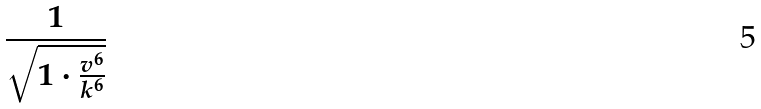<formula> <loc_0><loc_0><loc_500><loc_500>\frac { 1 } { \sqrt { 1 \cdot \frac { v ^ { 6 } } { k ^ { 6 } } } }</formula> 